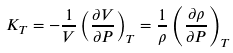Convert formula to latex. <formula><loc_0><loc_0><loc_500><loc_500>K _ { T } = - \frac { 1 } { V } \left ( \frac { \partial V } { \partial P } \right ) _ { T } = \frac { 1 } { \rho } \left ( \frac { \partial \rho } { \partial P } \right ) _ { T }</formula> 